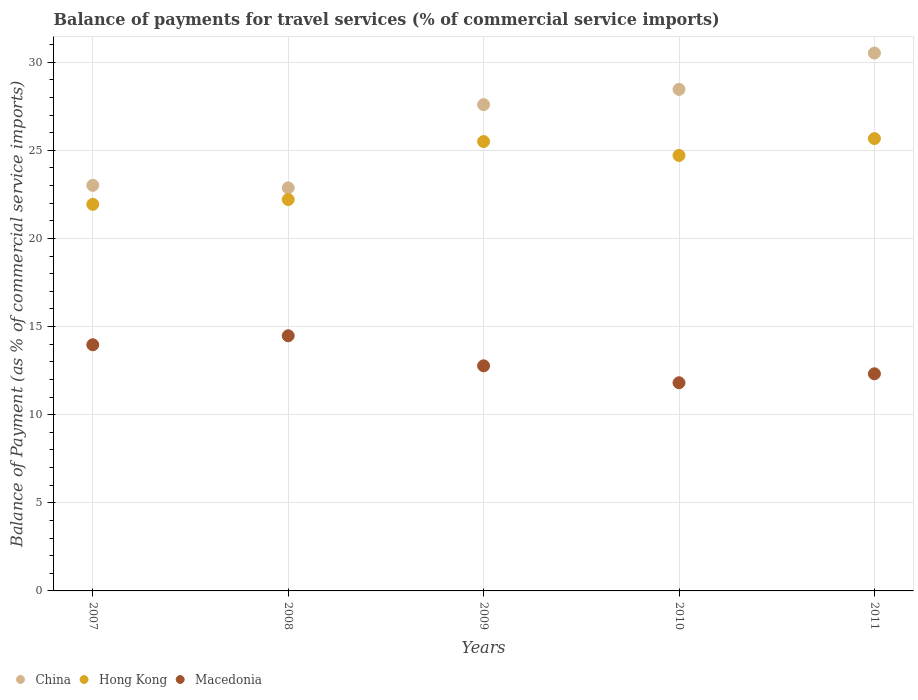Is the number of dotlines equal to the number of legend labels?
Provide a succinct answer. Yes. What is the balance of payments for travel services in China in 2010?
Ensure brevity in your answer.  28.46. Across all years, what is the maximum balance of payments for travel services in Macedonia?
Keep it short and to the point. 14.48. Across all years, what is the minimum balance of payments for travel services in Macedonia?
Provide a succinct answer. 11.81. What is the total balance of payments for travel services in Macedonia in the graph?
Your response must be concise. 65.35. What is the difference between the balance of payments for travel services in Hong Kong in 2009 and that in 2010?
Provide a succinct answer. 0.79. What is the difference between the balance of payments for travel services in Hong Kong in 2011 and the balance of payments for travel services in China in 2009?
Your response must be concise. -1.93. What is the average balance of payments for travel services in Hong Kong per year?
Provide a short and direct response. 24. In the year 2009, what is the difference between the balance of payments for travel services in Hong Kong and balance of payments for travel services in Macedonia?
Provide a short and direct response. 12.72. In how many years, is the balance of payments for travel services in Macedonia greater than 18 %?
Your response must be concise. 0. What is the ratio of the balance of payments for travel services in Macedonia in 2010 to that in 2011?
Your response must be concise. 0.96. Is the balance of payments for travel services in China in 2007 less than that in 2008?
Your answer should be compact. No. Is the difference between the balance of payments for travel services in Hong Kong in 2007 and 2009 greater than the difference between the balance of payments for travel services in Macedonia in 2007 and 2009?
Offer a very short reply. No. What is the difference between the highest and the second highest balance of payments for travel services in China?
Keep it short and to the point. 2.06. What is the difference between the highest and the lowest balance of payments for travel services in Hong Kong?
Give a very brief answer. 3.73. In how many years, is the balance of payments for travel services in China greater than the average balance of payments for travel services in China taken over all years?
Offer a terse response. 3. Is the balance of payments for travel services in Macedonia strictly greater than the balance of payments for travel services in China over the years?
Keep it short and to the point. No. Does the graph contain any zero values?
Your response must be concise. No. Does the graph contain grids?
Provide a short and direct response. Yes. What is the title of the graph?
Give a very brief answer. Balance of payments for travel services (% of commercial service imports). What is the label or title of the X-axis?
Make the answer very short. Years. What is the label or title of the Y-axis?
Provide a short and direct response. Balance of Payment (as % of commercial service imports). What is the Balance of Payment (as % of commercial service imports) of China in 2007?
Your answer should be compact. 23.01. What is the Balance of Payment (as % of commercial service imports) in Hong Kong in 2007?
Provide a short and direct response. 21.93. What is the Balance of Payment (as % of commercial service imports) in Macedonia in 2007?
Make the answer very short. 13.97. What is the Balance of Payment (as % of commercial service imports) of China in 2008?
Your response must be concise. 22.87. What is the Balance of Payment (as % of commercial service imports) of Hong Kong in 2008?
Keep it short and to the point. 22.21. What is the Balance of Payment (as % of commercial service imports) in Macedonia in 2008?
Give a very brief answer. 14.48. What is the Balance of Payment (as % of commercial service imports) of China in 2009?
Your response must be concise. 27.59. What is the Balance of Payment (as % of commercial service imports) of Hong Kong in 2009?
Make the answer very short. 25.5. What is the Balance of Payment (as % of commercial service imports) in Macedonia in 2009?
Offer a terse response. 12.77. What is the Balance of Payment (as % of commercial service imports) in China in 2010?
Offer a very short reply. 28.46. What is the Balance of Payment (as % of commercial service imports) in Hong Kong in 2010?
Offer a terse response. 24.71. What is the Balance of Payment (as % of commercial service imports) in Macedonia in 2010?
Your response must be concise. 11.81. What is the Balance of Payment (as % of commercial service imports) in China in 2011?
Keep it short and to the point. 30.52. What is the Balance of Payment (as % of commercial service imports) in Hong Kong in 2011?
Offer a very short reply. 25.67. What is the Balance of Payment (as % of commercial service imports) in Macedonia in 2011?
Give a very brief answer. 12.32. Across all years, what is the maximum Balance of Payment (as % of commercial service imports) of China?
Give a very brief answer. 30.52. Across all years, what is the maximum Balance of Payment (as % of commercial service imports) in Hong Kong?
Keep it short and to the point. 25.67. Across all years, what is the maximum Balance of Payment (as % of commercial service imports) of Macedonia?
Your response must be concise. 14.48. Across all years, what is the minimum Balance of Payment (as % of commercial service imports) of China?
Ensure brevity in your answer.  22.87. Across all years, what is the minimum Balance of Payment (as % of commercial service imports) in Hong Kong?
Provide a succinct answer. 21.93. Across all years, what is the minimum Balance of Payment (as % of commercial service imports) in Macedonia?
Provide a succinct answer. 11.81. What is the total Balance of Payment (as % of commercial service imports) in China in the graph?
Your response must be concise. 132.45. What is the total Balance of Payment (as % of commercial service imports) of Hong Kong in the graph?
Offer a terse response. 120.01. What is the total Balance of Payment (as % of commercial service imports) of Macedonia in the graph?
Provide a succinct answer. 65.35. What is the difference between the Balance of Payment (as % of commercial service imports) of China in 2007 and that in 2008?
Keep it short and to the point. 0.14. What is the difference between the Balance of Payment (as % of commercial service imports) of Hong Kong in 2007 and that in 2008?
Provide a succinct answer. -0.27. What is the difference between the Balance of Payment (as % of commercial service imports) of Macedonia in 2007 and that in 2008?
Your answer should be compact. -0.51. What is the difference between the Balance of Payment (as % of commercial service imports) of China in 2007 and that in 2009?
Provide a succinct answer. -4.58. What is the difference between the Balance of Payment (as % of commercial service imports) of Hong Kong in 2007 and that in 2009?
Ensure brevity in your answer.  -3.56. What is the difference between the Balance of Payment (as % of commercial service imports) of Macedonia in 2007 and that in 2009?
Provide a succinct answer. 1.19. What is the difference between the Balance of Payment (as % of commercial service imports) in China in 2007 and that in 2010?
Your answer should be very brief. -5.44. What is the difference between the Balance of Payment (as % of commercial service imports) in Hong Kong in 2007 and that in 2010?
Your response must be concise. -2.77. What is the difference between the Balance of Payment (as % of commercial service imports) of Macedonia in 2007 and that in 2010?
Your answer should be compact. 2.16. What is the difference between the Balance of Payment (as % of commercial service imports) in China in 2007 and that in 2011?
Provide a succinct answer. -7.5. What is the difference between the Balance of Payment (as % of commercial service imports) of Hong Kong in 2007 and that in 2011?
Make the answer very short. -3.73. What is the difference between the Balance of Payment (as % of commercial service imports) in Macedonia in 2007 and that in 2011?
Ensure brevity in your answer.  1.65. What is the difference between the Balance of Payment (as % of commercial service imports) in China in 2008 and that in 2009?
Offer a terse response. -4.72. What is the difference between the Balance of Payment (as % of commercial service imports) in Hong Kong in 2008 and that in 2009?
Your answer should be compact. -3.29. What is the difference between the Balance of Payment (as % of commercial service imports) in Macedonia in 2008 and that in 2009?
Make the answer very short. 1.7. What is the difference between the Balance of Payment (as % of commercial service imports) of China in 2008 and that in 2010?
Make the answer very short. -5.59. What is the difference between the Balance of Payment (as % of commercial service imports) in Hong Kong in 2008 and that in 2010?
Provide a short and direct response. -2.5. What is the difference between the Balance of Payment (as % of commercial service imports) of Macedonia in 2008 and that in 2010?
Offer a terse response. 2.67. What is the difference between the Balance of Payment (as % of commercial service imports) in China in 2008 and that in 2011?
Provide a short and direct response. -7.65. What is the difference between the Balance of Payment (as % of commercial service imports) of Hong Kong in 2008 and that in 2011?
Offer a terse response. -3.46. What is the difference between the Balance of Payment (as % of commercial service imports) in Macedonia in 2008 and that in 2011?
Your answer should be very brief. 2.16. What is the difference between the Balance of Payment (as % of commercial service imports) in China in 2009 and that in 2010?
Make the answer very short. -0.87. What is the difference between the Balance of Payment (as % of commercial service imports) in Hong Kong in 2009 and that in 2010?
Keep it short and to the point. 0.79. What is the difference between the Balance of Payment (as % of commercial service imports) of Macedonia in 2009 and that in 2010?
Offer a very short reply. 0.96. What is the difference between the Balance of Payment (as % of commercial service imports) of China in 2009 and that in 2011?
Make the answer very short. -2.93. What is the difference between the Balance of Payment (as % of commercial service imports) in Hong Kong in 2009 and that in 2011?
Give a very brief answer. -0.17. What is the difference between the Balance of Payment (as % of commercial service imports) of Macedonia in 2009 and that in 2011?
Make the answer very short. 0.45. What is the difference between the Balance of Payment (as % of commercial service imports) in China in 2010 and that in 2011?
Give a very brief answer. -2.06. What is the difference between the Balance of Payment (as % of commercial service imports) of Hong Kong in 2010 and that in 2011?
Give a very brief answer. -0.96. What is the difference between the Balance of Payment (as % of commercial service imports) in Macedonia in 2010 and that in 2011?
Make the answer very short. -0.51. What is the difference between the Balance of Payment (as % of commercial service imports) of China in 2007 and the Balance of Payment (as % of commercial service imports) of Hong Kong in 2008?
Provide a short and direct response. 0.81. What is the difference between the Balance of Payment (as % of commercial service imports) in China in 2007 and the Balance of Payment (as % of commercial service imports) in Macedonia in 2008?
Your answer should be very brief. 8.54. What is the difference between the Balance of Payment (as % of commercial service imports) of Hong Kong in 2007 and the Balance of Payment (as % of commercial service imports) of Macedonia in 2008?
Offer a very short reply. 7.46. What is the difference between the Balance of Payment (as % of commercial service imports) of China in 2007 and the Balance of Payment (as % of commercial service imports) of Hong Kong in 2009?
Offer a very short reply. -2.48. What is the difference between the Balance of Payment (as % of commercial service imports) in China in 2007 and the Balance of Payment (as % of commercial service imports) in Macedonia in 2009?
Offer a terse response. 10.24. What is the difference between the Balance of Payment (as % of commercial service imports) of Hong Kong in 2007 and the Balance of Payment (as % of commercial service imports) of Macedonia in 2009?
Provide a succinct answer. 9.16. What is the difference between the Balance of Payment (as % of commercial service imports) of China in 2007 and the Balance of Payment (as % of commercial service imports) of Hong Kong in 2010?
Your answer should be compact. -1.7. What is the difference between the Balance of Payment (as % of commercial service imports) of China in 2007 and the Balance of Payment (as % of commercial service imports) of Macedonia in 2010?
Your response must be concise. 11.2. What is the difference between the Balance of Payment (as % of commercial service imports) in Hong Kong in 2007 and the Balance of Payment (as % of commercial service imports) in Macedonia in 2010?
Your answer should be compact. 10.12. What is the difference between the Balance of Payment (as % of commercial service imports) of China in 2007 and the Balance of Payment (as % of commercial service imports) of Hong Kong in 2011?
Give a very brief answer. -2.65. What is the difference between the Balance of Payment (as % of commercial service imports) in China in 2007 and the Balance of Payment (as % of commercial service imports) in Macedonia in 2011?
Offer a terse response. 10.69. What is the difference between the Balance of Payment (as % of commercial service imports) in Hong Kong in 2007 and the Balance of Payment (as % of commercial service imports) in Macedonia in 2011?
Your answer should be very brief. 9.61. What is the difference between the Balance of Payment (as % of commercial service imports) of China in 2008 and the Balance of Payment (as % of commercial service imports) of Hong Kong in 2009?
Offer a terse response. -2.63. What is the difference between the Balance of Payment (as % of commercial service imports) in China in 2008 and the Balance of Payment (as % of commercial service imports) in Macedonia in 2009?
Offer a very short reply. 10.1. What is the difference between the Balance of Payment (as % of commercial service imports) in Hong Kong in 2008 and the Balance of Payment (as % of commercial service imports) in Macedonia in 2009?
Keep it short and to the point. 9.44. What is the difference between the Balance of Payment (as % of commercial service imports) in China in 2008 and the Balance of Payment (as % of commercial service imports) in Hong Kong in 2010?
Your response must be concise. -1.84. What is the difference between the Balance of Payment (as % of commercial service imports) in China in 2008 and the Balance of Payment (as % of commercial service imports) in Macedonia in 2010?
Provide a succinct answer. 11.06. What is the difference between the Balance of Payment (as % of commercial service imports) of Hong Kong in 2008 and the Balance of Payment (as % of commercial service imports) of Macedonia in 2010?
Your response must be concise. 10.4. What is the difference between the Balance of Payment (as % of commercial service imports) in China in 2008 and the Balance of Payment (as % of commercial service imports) in Hong Kong in 2011?
Give a very brief answer. -2.8. What is the difference between the Balance of Payment (as % of commercial service imports) of China in 2008 and the Balance of Payment (as % of commercial service imports) of Macedonia in 2011?
Provide a short and direct response. 10.55. What is the difference between the Balance of Payment (as % of commercial service imports) in Hong Kong in 2008 and the Balance of Payment (as % of commercial service imports) in Macedonia in 2011?
Give a very brief answer. 9.89. What is the difference between the Balance of Payment (as % of commercial service imports) in China in 2009 and the Balance of Payment (as % of commercial service imports) in Hong Kong in 2010?
Your answer should be very brief. 2.88. What is the difference between the Balance of Payment (as % of commercial service imports) in China in 2009 and the Balance of Payment (as % of commercial service imports) in Macedonia in 2010?
Your answer should be compact. 15.78. What is the difference between the Balance of Payment (as % of commercial service imports) of Hong Kong in 2009 and the Balance of Payment (as % of commercial service imports) of Macedonia in 2010?
Your answer should be very brief. 13.69. What is the difference between the Balance of Payment (as % of commercial service imports) of China in 2009 and the Balance of Payment (as % of commercial service imports) of Hong Kong in 2011?
Offer a terse response. 1.93. What is the difference between the Balance of Payment (as % of commercial service imports) in China in 2009 and the Balance of Payment (as % of commercial service imports) in Macedonia in 2011?
Give a very brief answer. 15.27. What is the difference between the Balance of Payment (as % of commercial service imports) of Hong Kong in 2009 and the Balance of Payment (as % of commercial service imports) of Macedonia in 2011?
Your response must be concise. 13.18. What is the difference between the Balance of Payment (as % of commercial service imports) in China in 2010 and the Balance of Payment (as % of commercial service imports) in Hong Kong in 2011?
Your answer should be very brief. 2.79. What is the difference between the Balance of Payment (as % of commercial service imports) of China in 2010 and the Balance of Payment (as % of commercial service imports) of Macedonia in 2011?
Keep it short and to the point. 16.14. What is the difference between the Balance of Payment (as % of commercial service imports) of Hong Kong in 2010 and the Balance of Payment (as % of commercial service imports) of Macedonia in 2011?
Your response must be concise. 12.39. What is the average Balance of Payment (as % of commercial service imports) of China per year?
Your answer should be very brief. 26.49. What is the average Balance of Payment (as % of commercial service imports) in Hong Kong per year?
Give a very brief answer. 24. What is the average Balance of Payment (as % of commercial service imports) of Macedonia per year?
Provide a short and direct response. 13.07. In the year 2007, what is the difference between the Balance of Payment (as % of commercial service imports) of China and Balance of Payment (as % of commercial service imports) of Hong Kong?
Provide a succinct answer. 1.08. In the year 2007, what is the difference between the Balance of Payment (as % of commercial service imports) of China and Balance of Payment (as % of commercial service imports) of Macedonia?
Provide a short and direct response. 9.05. In the year 2007, what is the difference between the Balance of Payment (as % of commercial service imports) of Hong Kong and Balance of Payment (as % of commercial service imports) of Macedonia?
Give a very brief answer. 7.97. In the year 2008, what is the difference between the Balance of Payment (as % of commercial service imports) of China and Balance of Payment (as % of commercial service imports) of Hong Kong?
Provide a succinct answer. 0.66. In the year 2008, what is the difference between the Balance of Payment (as % of commercial service imports) of China and Balance of Payment (as % of commercial service imports) of Macedonia?
Give a very brief answer. 8.39. In the year 2008, what is the difference between the Balance of Payment (as % of commercial service imports) of Hong Kong and Balance of Payment (as % of commercial service imports) of Macedonia?
Make the answer very short. 7.73. In the year 2009, what is the difference between the Balance of Payment (as % of commercial service imports) of China and Balance of Payment (as % of commercial service imports) of Hong Kong?
Your answer should be compact. 2.09. In the year 2009, what is the difference between the Balance of Payment (as % of commercial service imports) of China and Balance of Payment (as % of commercial service imports) of Macedonia?
Provide a short and direct response. 14.82. In the year 2009, what is the difference between the Balance of Payment (as % of commercial service imports) in Hong Kong and Balance of Payment (as % of commercial service imports) in Macedonia?
Your answer should be very brief. 12.72. In the year 2010, what is the difference between the Balance of Payment (as % of commercial service imports) in China and Balance of Payment (as % of commercial service imports) in Hong Kong?
Offer a very short reply. 3.75. In the year 2010, what is the difference between the Balance of Payment (as % of commercial service imports) in China and Balance of Payment (as % of commercial service imports) in Macedonia?
Your answer should be compact. 16.65. In the year 2010, what is the difference between the Balance of Payment (as % of commercial service imports) of Hong Kong and Balance of Payment (as % of commercial service imports) of Macedonia?
Offer a terse response. 12.9. In the year 2011, what is the difference between the Balance of Payment (as % of commercial service imports) of China and Balance of Payment (as % of commercial service imports) of Hong Kong?
Ensure brevity in your answer.  4.85. In the year 2011, what is the difference between the Balance of Payment (as % of commercial service imports) of China and Balance of Payment (as % of commercial service imports) of Macedonia?
Offer a terse response. 18.2. In the year 2011, what is the difference between the Balance of Payment (as % of commercial service imports) of Hong Kong and Balance of Payment (as % of commercial service imports) of Macedonia?
Make the answer very short. 13.35. What is the ratio of the Balance of Payment (as % of commercial service imports) in China in 2007 to that in 2008?
Your response must be concise. 1.01. What is the ratio of the Balance of Payment (as % of commercial service imports) of Macedonia in 2007 to that in 2008?
Offer a terse response. 0.96. What is the ratio of the Balance of Payment (as % of commercial service imports) of China in 2007 to that in 2009?
Ensure brevity in your answer.  0.83. What is the ratio of the Balance of Payment (as % of commercial service imports) in Hong Kong in 2007 to that in 2009?
Provide a succinct answer. 0.86. What is the ratio of the Balance of Payment (as % of commercial service imports) of Macedonia in 2007 to that in 2009?
Offer a terse response. 1.09. What is the ratio of the Balance of Payment (as % of commercial service imports) in China in 2007 to that in 2010?
Make the answer very short. 0.81. What is the ratio of the Balance of Payment (as % of commercial service imports) in Hong Kong in 2007 to that in 2010?
Your answer should be compact. 0.89. What is the ratio of the Balance of Payment (as % of commercial service imports) of Macedonia in 2007 to that in 2010?
Your answer should be very brief. 1.18. What is the ratio of the Balance of Payment (as % of commercial service imports) in China in 2007 to that in 2011?
Your answer should be compact. 0.75. What is the ratio of the Balance of Payment (as % of commercial service imports) of Hong Kong in 2007 to that in 2011?
Ensure brevity in your answer.  0.85. What is the ratio of the Balance of Payment (as % of commercial service imports) of Macedonia in 2007 to that in 2011?
Ensure brevity in your answer.  1.13. What is the ratio of the Balance of Payment (as % of commercial service imports) of China in 2008 to that in 2009?
Provide a short and direct response. 0.83. What is the ratio of the Balance of Payment (as % of commercial service imports) of Hong Kong in 2008 to that in 2009?
Offer a terse response. 0.87. What is the ratio of the Balance of Payment (as % of commercial service imports) in Macedonia in 2008 to that in 2009?
Your answer should be very brief. 1.13. What is the ratio of the Balance of Payment (as % of commercial service imports) of China in 2008 to that in 2010?
Your answer should be very brief. 0.8. What is the ratio of the Balance of Payment (as % of commercial service imports) in Hong Kong in 2008 to that in 2010?
Offer a terse response. 0.9. What is the ratio of the Balance of Payment (as % of commercial service imports) of Macedonia in 2008 to that in 2010?
Provide a succinct answer. 1.23. What is the ratio of the Balance of Payment (as % of commercial service imports) in China in 2008 to that in 2011?
Your response must be concise. 0.75. What is the ratio of the Balance of Payment (as % of commercial service imports) of Hong Kong in 2008 to that in 2011?
Make the answer very short. 0.87. What is the ratio of the Balance of Payment (as % of commercial service imports) in Macedonia in 2008 to that in 2011?
Provide a succinct answer. 1.18. What is the ratio of the Balance of Payment (as % of commercial service imports) of China in 2009 to that in 2010?
Give a very brief answer. 0.97. What is the ratio of the Balance of Payment (as % of commercial service imports) in Hong Kong in 2009 to that in 2010?
Provide a short and direct response. 1.03. What is the ratio of the Balance of Payment (as % of commercial service imports) of Macedonia in 2009 to that in 2010?
Provide a short and direct response. 1.08. What is the ratio of the Balance of Payment (as % of commercial service imports) in China in 2009 to that in 2011?
Provide a short and direct response. 0.9. What is the ratio of the Balance of Payment (as % of commercial service imports) in Hong Kong in 2009 to that in 2011?
Your response must be concise. 0.99. What is the ratio of the Balance of Payment (as % of commercial service imports) in Macedonia in 2009 to that in 2011?
Ensure brevity in your answer.  1.04. What is the ratio of the Balance of Payment (as % of commercial service imports) in China in 2010 to that in 2011?
Your answer should be compact. 0.93. What is the ratio of the Balance of Payment (as % of commercial service imports) of Hong Kong in 2010 to that in 2011?
Your answer should be compact. 0.96. What is the ratio of the Balance of Payment (as % of commercial service imports) of Macedonia in 2010 to that in 2011?
Your response must be concise. 0.96. What is the difference between the highest and the second highest Balance of Payment (as % of commercial service imports) in China?
Offer a terse response. 2.06. What is the difference between the highest and the second highest Balance of Payment (as % of commercial service imports) in Hong Kong?
Provide a succinct answer. 0.17. What is the difference between the highest and the second highest Balance of Payment (as % of commercial service imports) in Macedonia?
Your answer should be compact. 0.51. What is the difference between the highest and the lowest Balance of Payment (as % of commercial service imports) of China?
Ensure brevity in your answer.  7.65. What is the difference between the highest and the lowest Balance of Payment (as % of commercial service imports) of Hong Kong?
Make the answer very short. 3.73. What is the difference between the highest and the lowest Balance of Payment (as % of commercial service imports) of Macedonia?
Give a very brief answer. 2.67. 